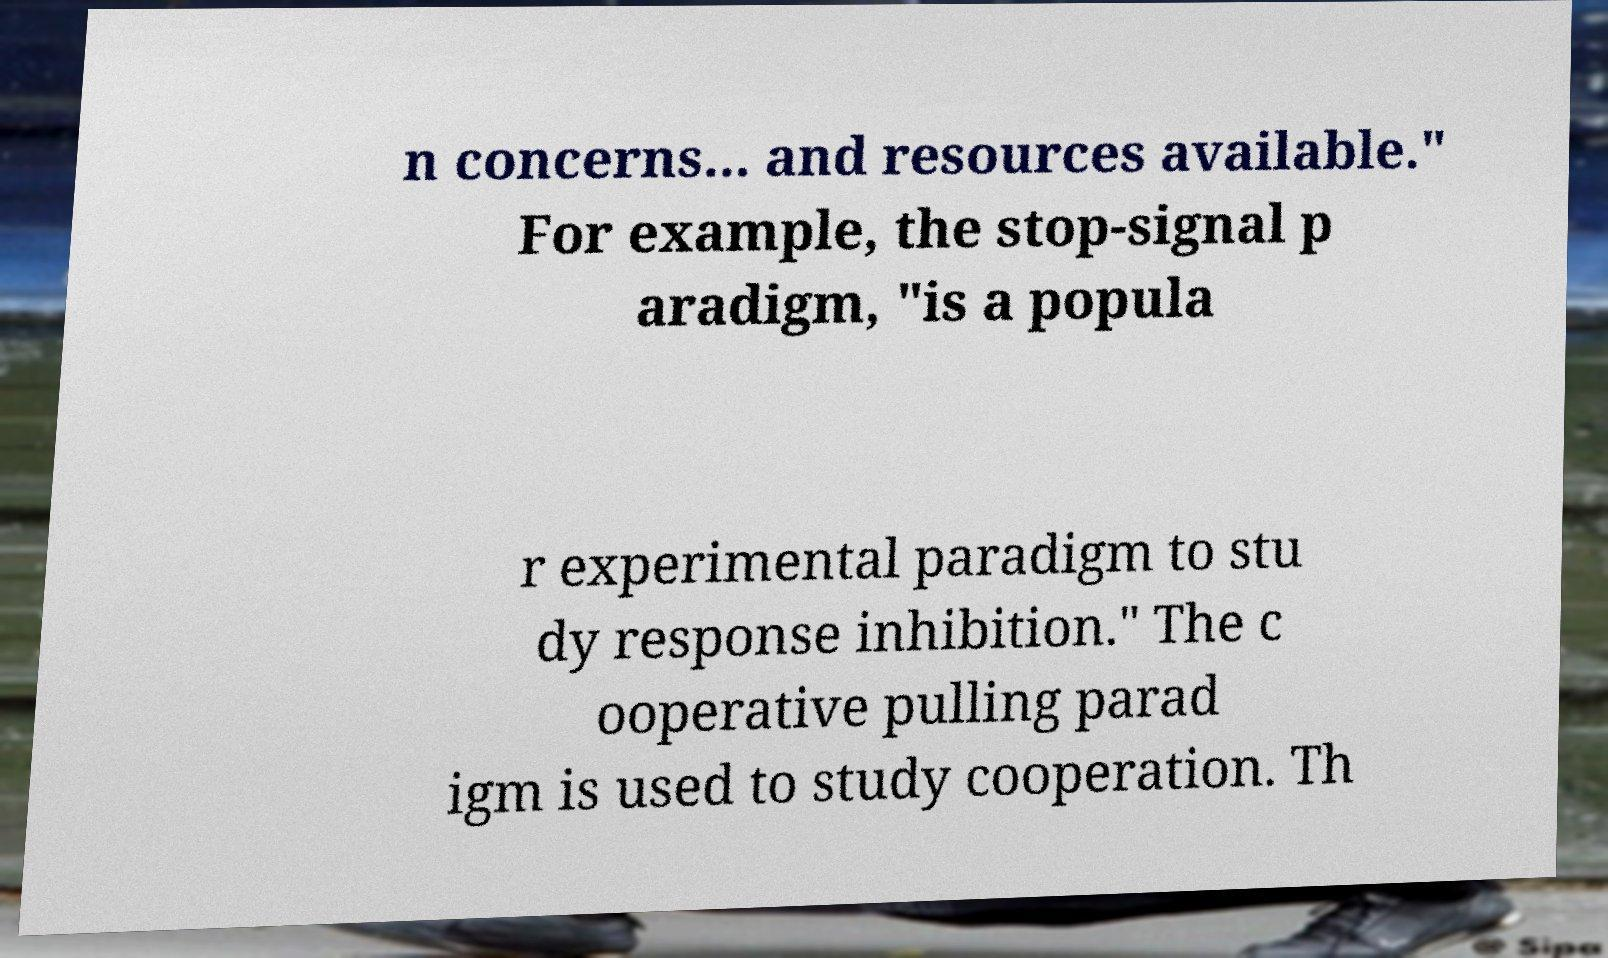Please identify and transcribe the text found in this image. n concerns... and resources available." For example, the stop-signal p aradigm, "is a popula r experimental paradigm to stu dy response inhibition." The c ooperative pulling parad igm is used to study cooperation. Th 